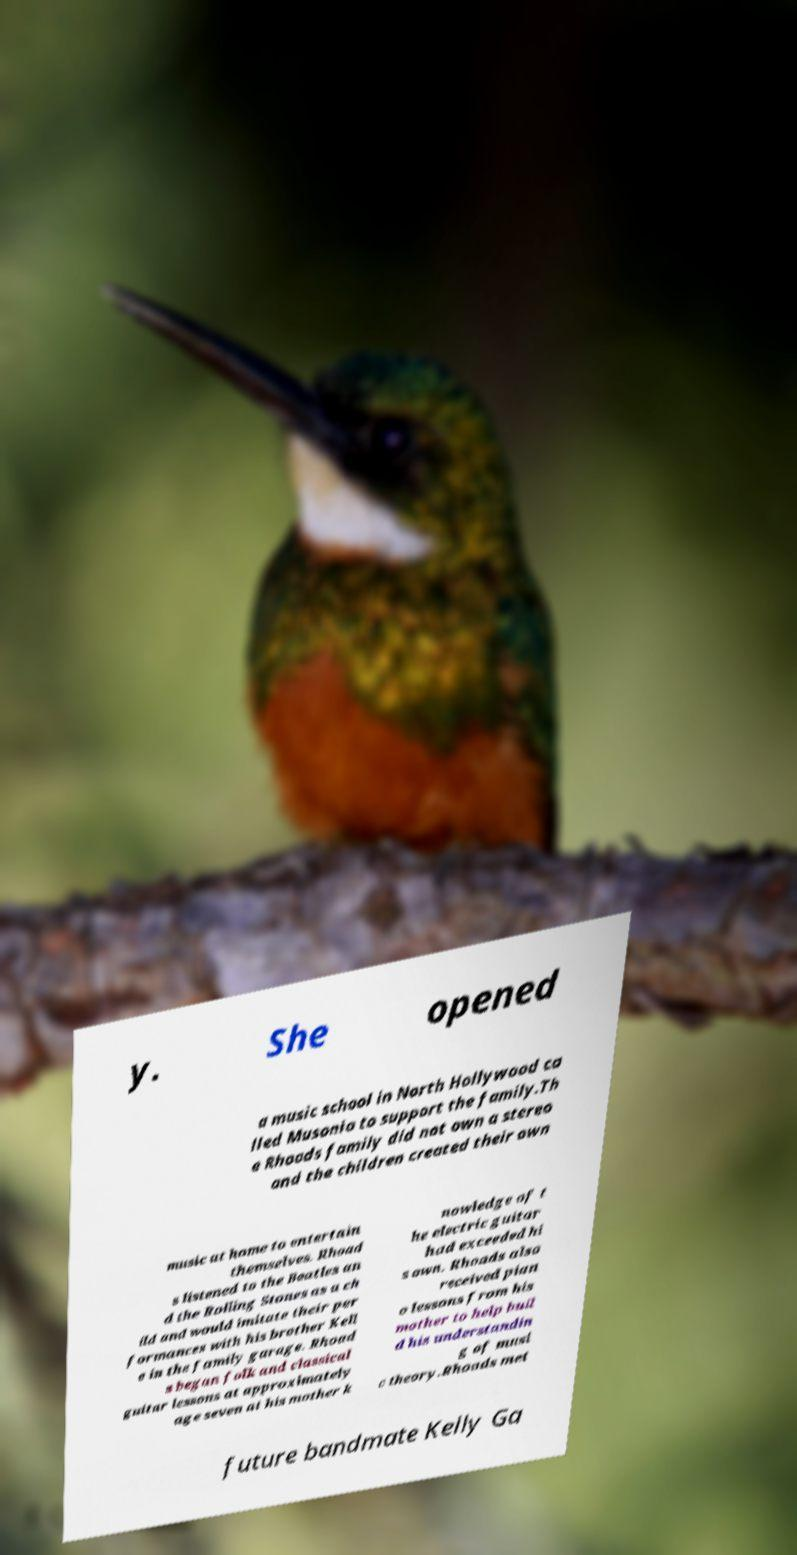What messages or text are displayed in this image? I need them in a readable, typed format. y. She opened a music school in North Hollywood ca lled Musonia to support the family.Th e Rhoads family did not own a stereo and the children created their own music at home to entertain themselves. Rhoad s listened to the Beatles an d the Rolling Stones as a ch ild and would imitate their per formances with his brother Kell e in the family garage. Rhoad s began folk and classical guitar lessons at approximately age seven at his mother k nowledge of t he electric guitar had exceeded hi s own. Rhoads also received pian o lessons from his mother to help buil d his understandin g of musi c theory.Rhoads met future bandmate Kelly Ga 